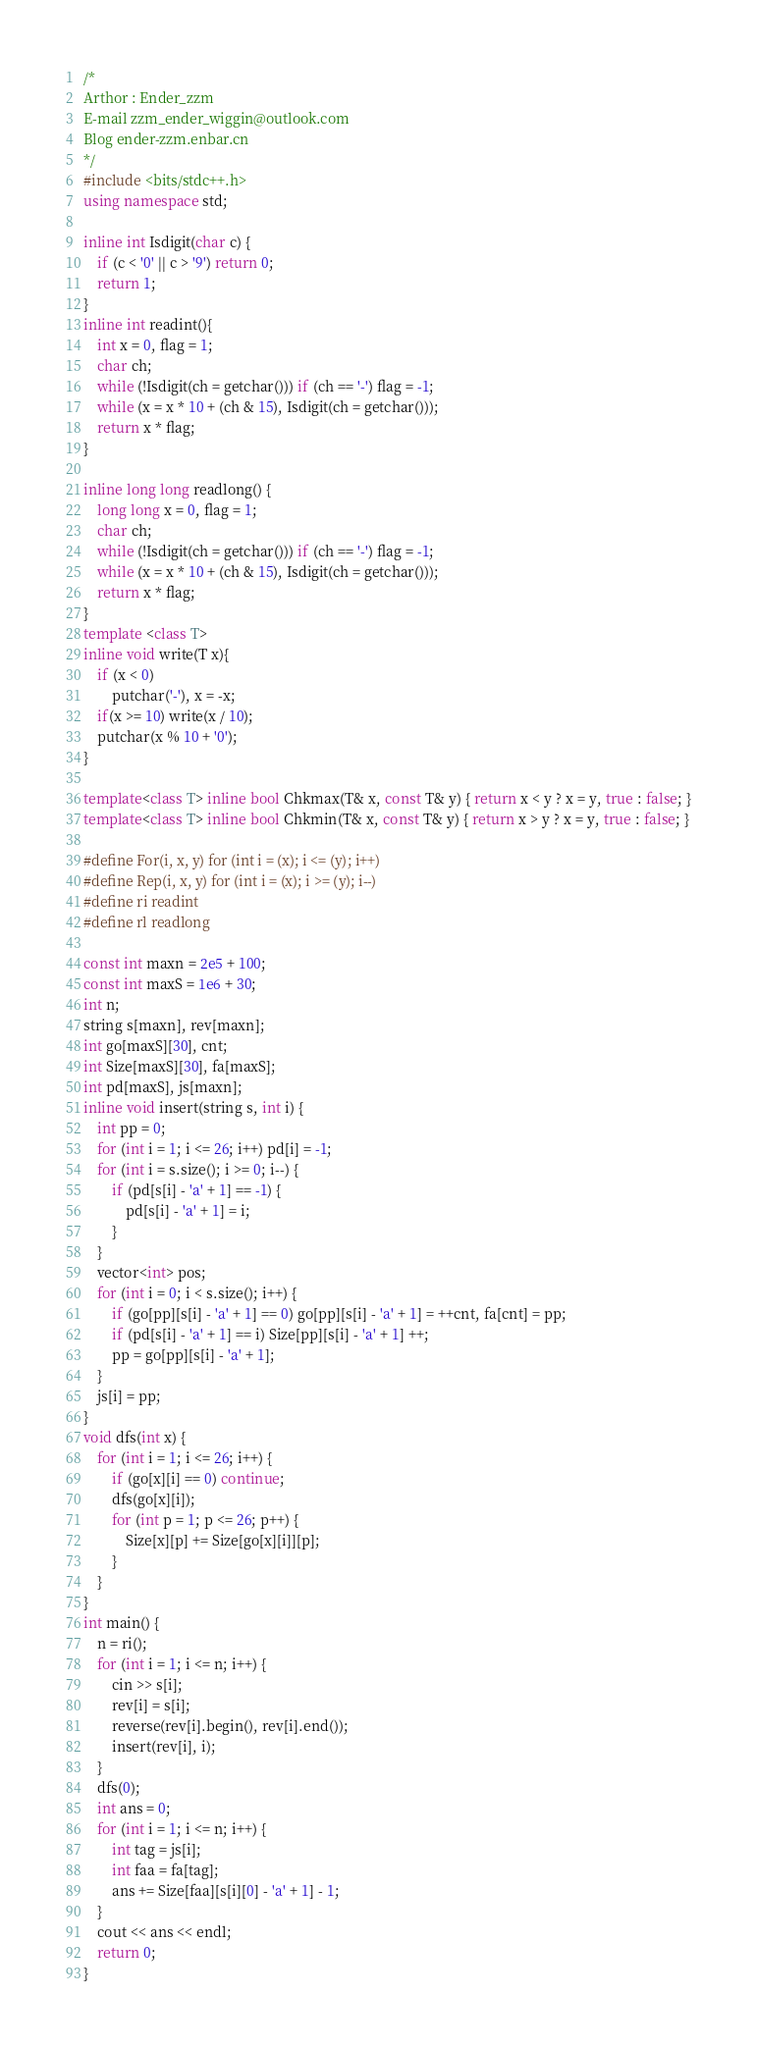<code> <loc_0><loc_0><loc_500><loc_500><_C++_>/*
Arthor : Ender_zzm
E-mail zzm_ender_wiggin@outlook.com
Blog ender-zzm.enbar.cn
*/
#include <bits/stdc++.h>
using namespace std;

inline int Isdigit(char c) {
	if (c < '0' || c > '9') return 0;
	return 1;
}
inline int readint(){
    int x = 0, flag = 1;
    char ch;
    while (!Isdigit(ch = getchar())) if (ch == '-') flag = -1;
    while (x = x * 10 + (ch & 15), Isdigit(ch = getchar()));
	return x * flag;
}

inline long long readlong() {
	long long x = 0, flag = 1;
	char ch;
	while (!Isdigit(ch = getchar())) if (ch == '-') flag = -1;
    while (x = x * 10 + (ch & 15), Isdigit(ch = getchar()));
	return x * flag;
}
template <class T>
inline void write(T x){
    if (x < 0)
        putchar('-'), x = -x;
    if(x >= 10) write(x / 10); 
    putchar(x % 10 + '0');
}

template<class T> inline bool Chkmax(T& x, const T& y) { return x < y ? x = y, true : false; }
template<class T> inline bool Chkmin(T& x, const T& y) { return x > y ? x = y, true : false; }

#define For(i, x, y) for (int i = (x); i <= (y); i++) 
#define Rep(i, x, y) for (int i = (x); i >= (y); i--) 
#define ri readint
#define rl readlong

const int maxn = 2e5 + 100;
const int maxS = 1e6 + 30;
int n;
string s[maxn], rev[maxn];
int go[maxS][30], cnt;
int Size[maxS][30], fa[maxS];
int pd[maxS], js[maxn];
inline void insert(string s, int i) {
	int pp = 0;
	for (int i = 1; i <= 26; i++) pd[i] = -1;
	for (int i = s.size(); i >= 0; i--) {
		if (pd[s[i] - 'a' + 1] == -1) {
			pd[s[i] - 'a' + 1] = i;
		}
	}
	vector<int> pos;
	for (int i = 0; i < s.size(); i++) {
		if (go[pp][s[i] - 'a' + 1] == 0) go[pp][s[i] - 'a' + 1] = ++cnt, fa[cnt] = pp;
		if (pd[s[i] - 'a' + 1] == i) Size[pp][s[i] - 'a' + 1] ++;
		pp = go[pp][s[i] - 'a' + 1];
	}
	js[i] = pp;
}
void dfs(int x) {
	for (int i = 1; i <= 26; i++) {
		if (go[x][i] == 0) continue;
		dfs(go[x][i]);
		for (int p = 1; p <= 26; p++) {
			Size[x][p] += Size[go[x][i]][p];
		}
	}
}
int main() {
	n = ri(); 
	for (int i = 1; i <= n; i++) {
		cin >> s[i];
		rev[i] = s[i];
		reverse(rev[i].begin(), rev[i].end());
		insert(rev[i], i);
	}
	dfs(0);
	int ans = 0;
	for (int i = 1; i <= n; i++) {
		int tag = js[i];
		int faa = fa[tag];
		ans += Size[faa][s[i][0] - 'a' + 1] - 1;
	}
	cout << ans << endl;
	return 0;
}
</code> 